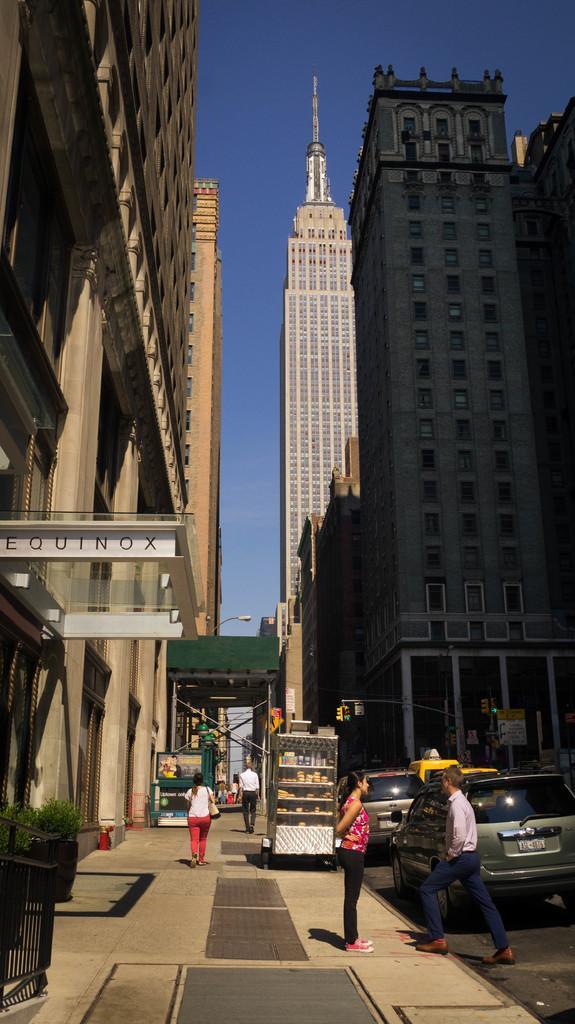Describe this image in one or two sentences. I can see three people walking and the woman standing. These are the cars on the road. I can see skyscrapers and buildings. This looks like a machine, which is placed on the footpath. Here is a flower pot with a small plant in it. 